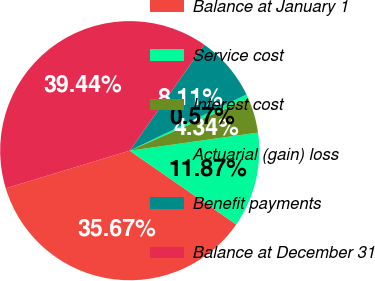<chart> <loc_0><loc_0><loc_500><loc_500><pie_chart><fcel>Balance at January 1<fcel>Service cost<fcel>Interest cost<fcel>Actuarial (gain) loss<fcel>Benefit payments<fcel>Balance at December 31<nl><fcel>35.67%<fcel>11.87%<fcel>4.34%<fcel>0.57%<fcel>8.11%<fcel>39.44%<nl></chart> 